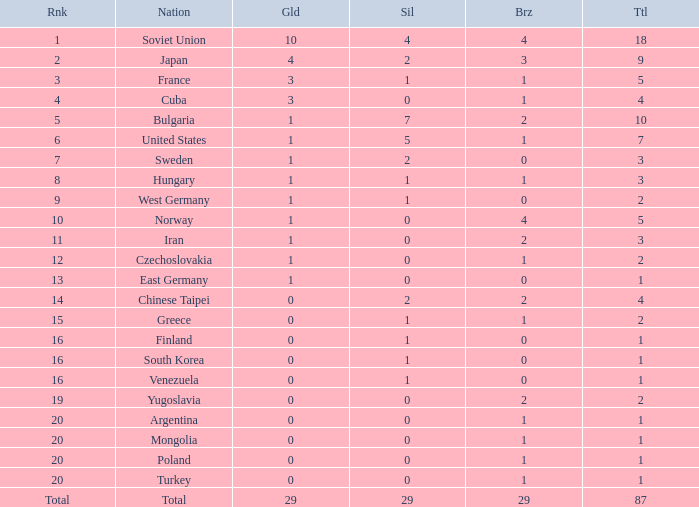Which rank has 1 silver medal and more than 1 gold medal? 3.0. 